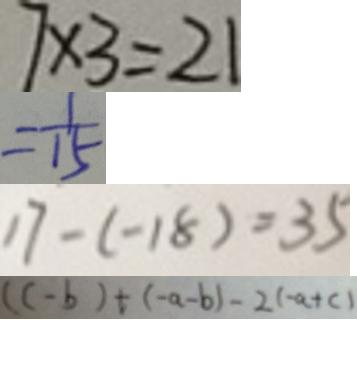<formula> <loc_0><loc_0><loc_500><loc_500>7 \times 3 = 2 1 
 = \frac { 1 } { 1 5 } 
 1 7 - ( - 1 8 ) = 3 5 
 ( c - b ) + ( - a - b ) - 2 ( - a + c )</formula> 